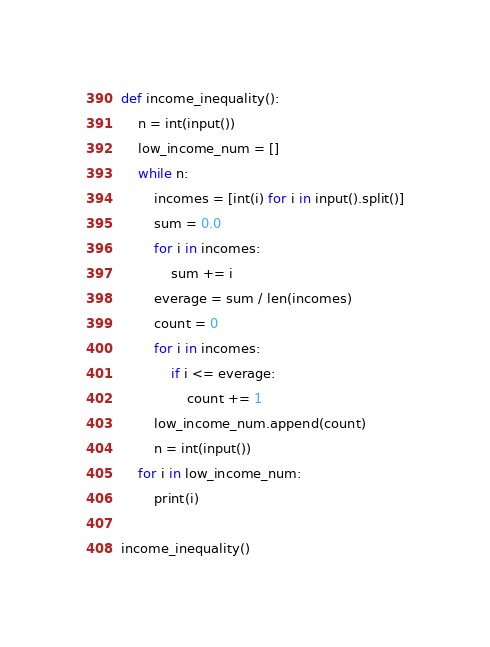<code> <loc_0><loc_0><loc_500><loc_500><_Python_>def income_inequality():
    n = int(input())
    low_income_num = []
    while n:
        incomes = [int(i) for i in input().split()]
        sum = 0.0
        for i in incomes:
            sum += i
        everage = sum / len(incomes)
        count = 0
        for i in incomes:
            if i <= everage:
                count += 1
        low_income_num.append(count)
        n = int(input())
    for i in low_income_num:
        print(i)

income_inequality()
</code> 